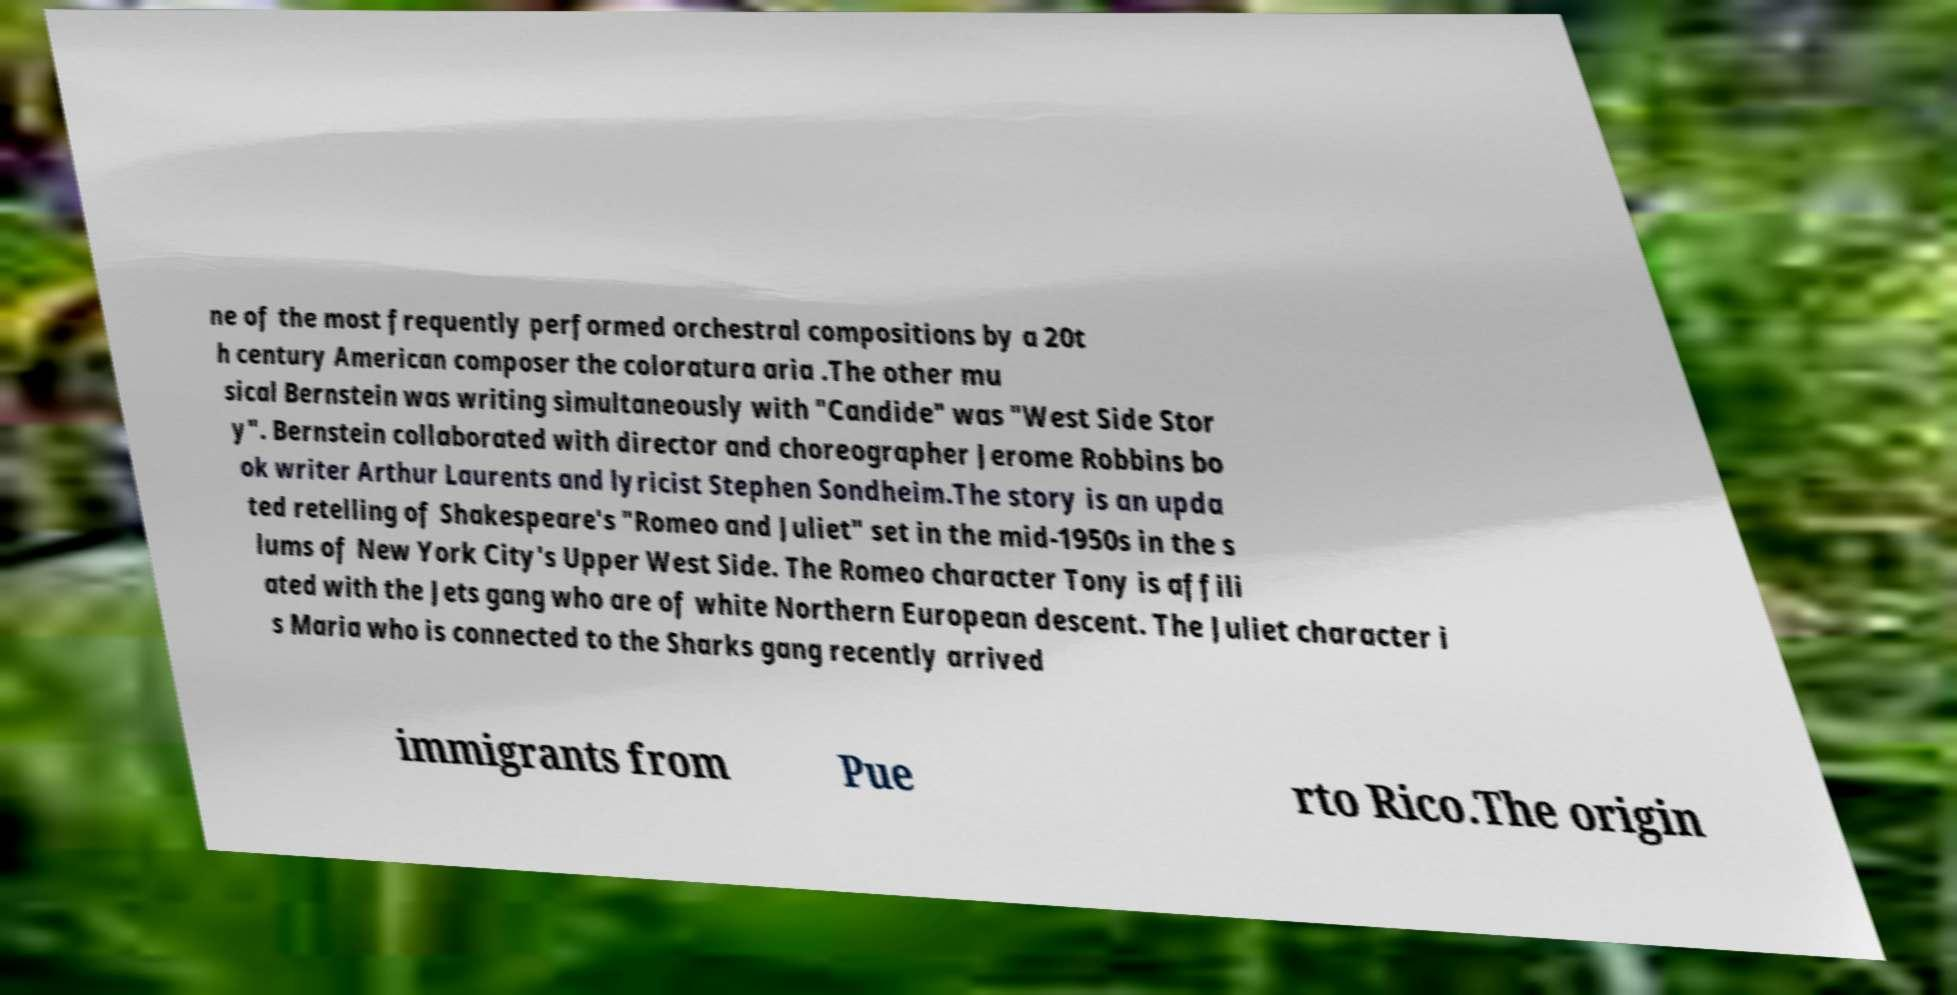Can you accurately transcribe the text from the provided image for me? ne of the most frequently performed orchestral compositions by a 20t h century American composer the coloratura aria .The other mu sical Bernstein was writing simultaneously with "Candide" was "West Side Stor y". Bernstein collaborated with director and choreographer Jerome Robbins bo ok writer Arthur Laurents and lyricist Stephen Sondheim.The story is an upda ted retelling of Shakespeare's "Romeo and Juliet" set in the mid-1950s in the s lums of New York City's Upper West Side. The Romeo character Tony is affili ated with the Jets gang who are of white Northern European descent. The Juliet character i s Maria who is connected to the Sharks gang recently arrived immigrants from Pue rto Rico.The origin 